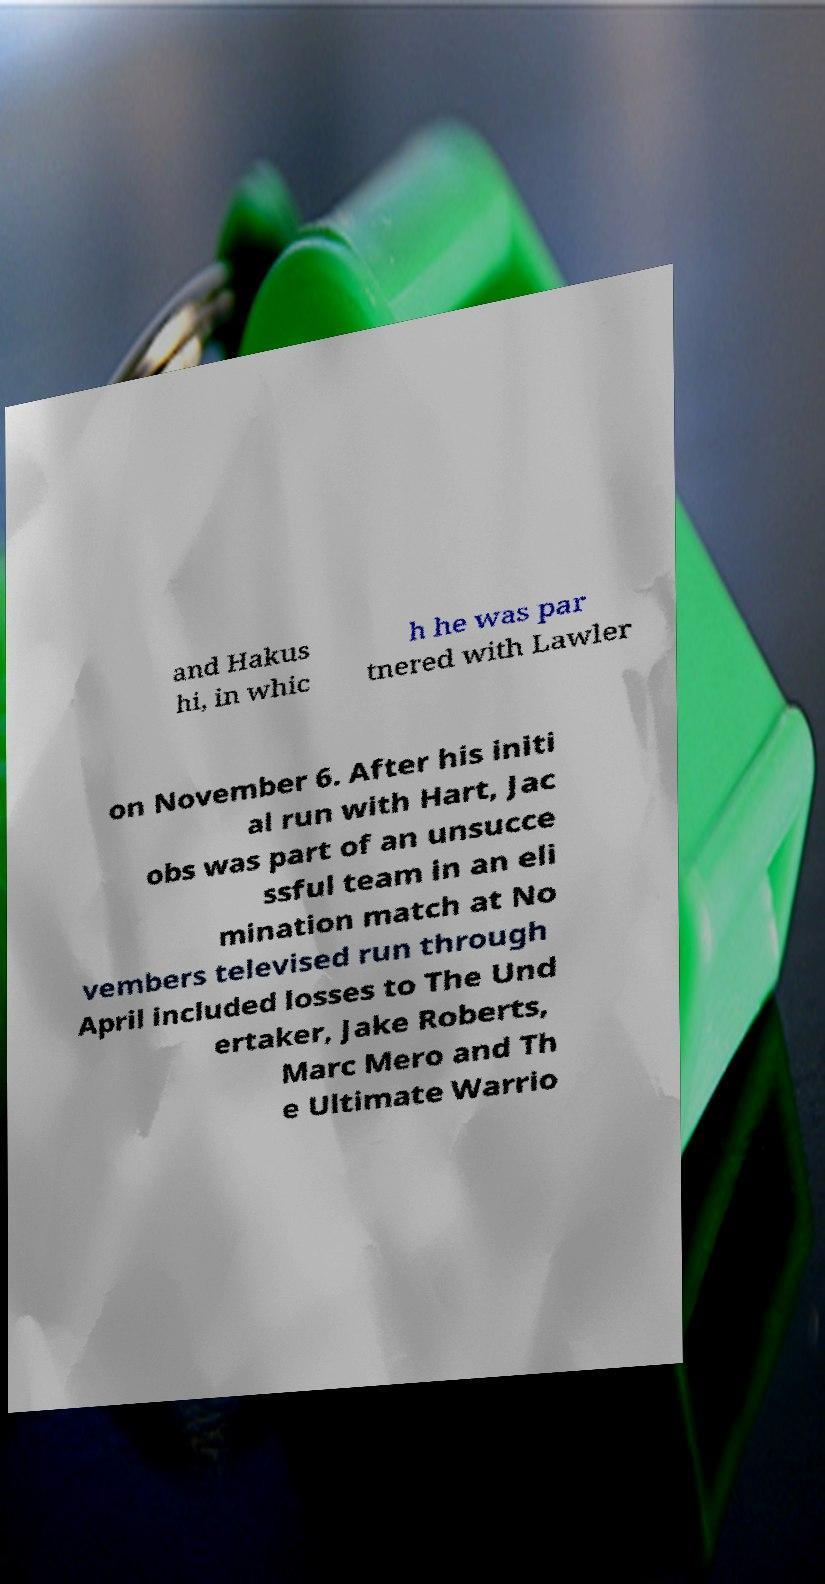Please identify and transcribe the text found in this image. and Hakus hi, in whic h he was par tnered with Lawler on November 6. After his initi al run with Hart, Jac obs was part of an unsucce ssful team in an eli mination match at No vembers televised run through April included losses to The Und ertaker, Jake Roberts, Marc Mero and Th e Ultimate Warrio 